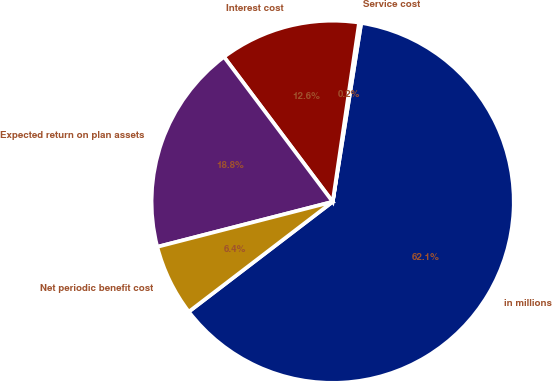<chart> <loc_0><loc_0><loc_500><loc_500><pie_chart><fcel>in millions<fcel>Service cost<fcel>Interest cost<fcel>Expected return on plan assets<fcel>Net periodic benefit cost<nl><fcel>62.09%<fcel>0.19%<fcel>12.57%<fcel>18.76%<fcel>6.38%<nl></chart> 